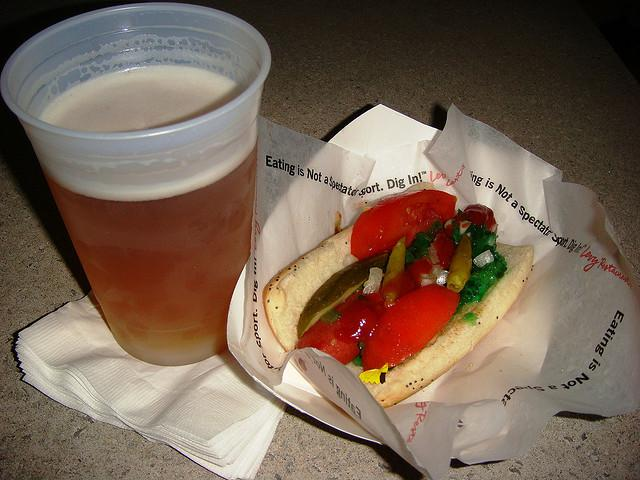What celebrity has a first name that is the same name as the red item in this tomato free sandwich?

Choices:
A) pepper keenan
B) watermelon o'gallagher
C) cherry smith
D) apple martin pepper keenan 